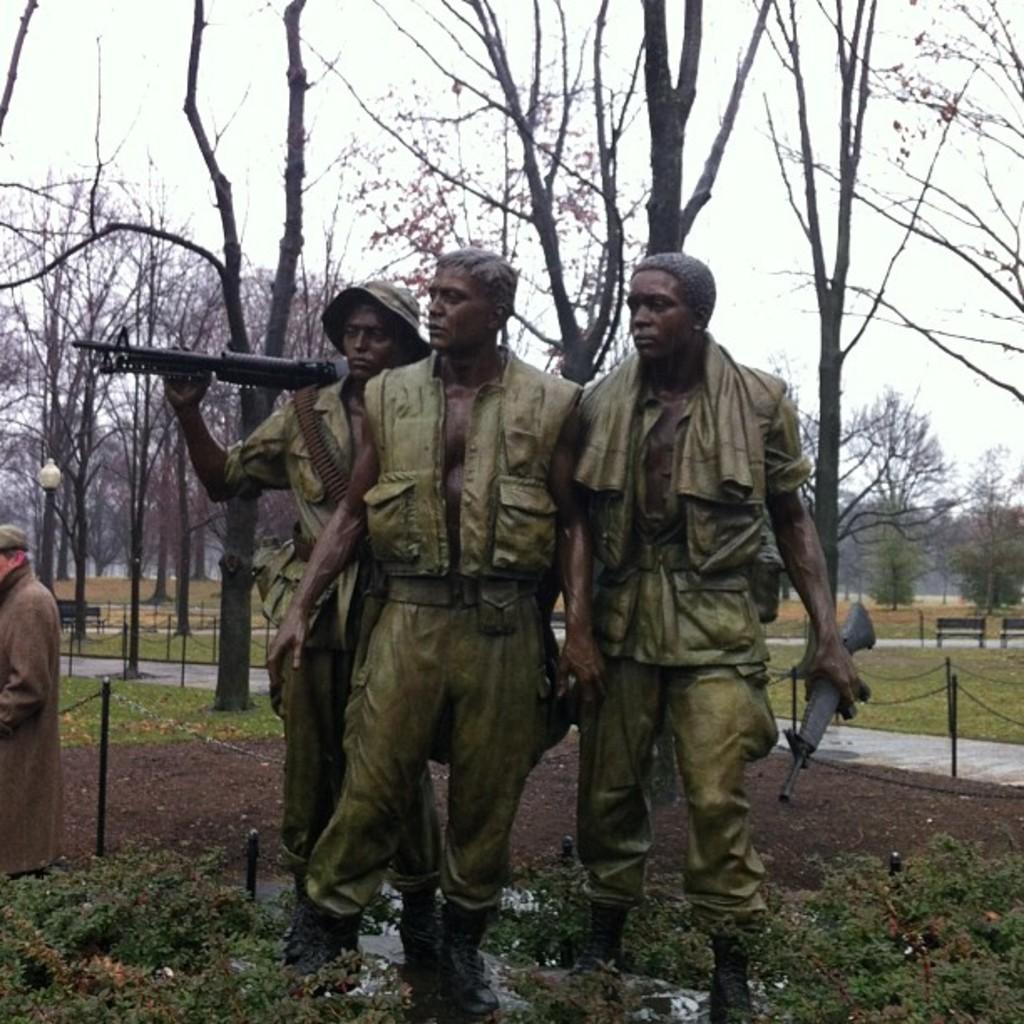Could you give a brief overview of what you see in this image? In this picture I can see sculptures of three persons, there are plants, chain barriers, there are benches, there is a person standing, there are trees, and in the background there is the sky. 